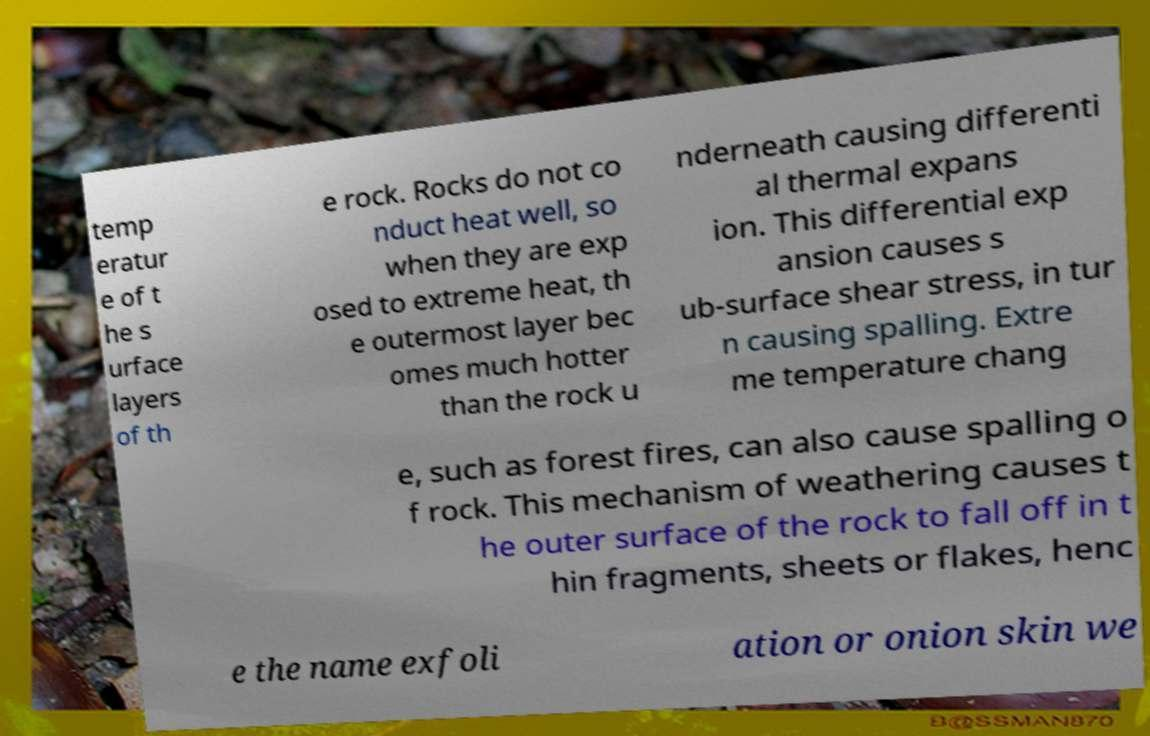What messages or text are displayed in this image? I need them in a readable, typed format. temp eratur e of t he s urface layers of th e rock. Rocks do not co nduct heat well, so when they are exp osed to extreme heat, th e outermost layer bec omes much hotter than the rock u nderneath causing differenti al thermal expans ion. This differential exp ansion causes s ub-surface shear stress, in tur n causing spalling. Extre me temperature chang e, such as forest fires, can also cause spalling o f rock. This mechanism of weathering causes t he outer surface of the rock to fall off in t hin fragments, sheets or flakes, henc e the name exfoli ation or onion skin we 